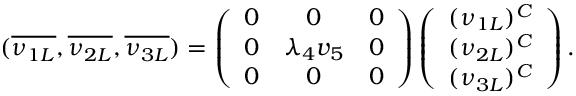<formula> <loc_0><loc_0><loc_500><loc_500>( \overline { { { \nu _ { 1 L } } } } , \overline { { { \nu _ { 2 L } } } } , \overline { { { \nu _ { 3 L } } } } ) = \left ( \begin{array} { c c c } { 0 } & { 0 } & { 0 } \\ { 0 } & { { \lambda _ { 4 } v _ { 5 } } } & { 0 } \\ { 0 } & { 0 } & { 0 } \end{array} \right ) \left ( \begin{array} { c } { { ( \nu _ { 1 L } ) ^ { C } } } \\ { { ( \nu _ { 2 L } ) ^ { C } } } \\ { { ( \nu _ { 3 L } ) ^ { C } } } \end{array} \right ) .</formula> 